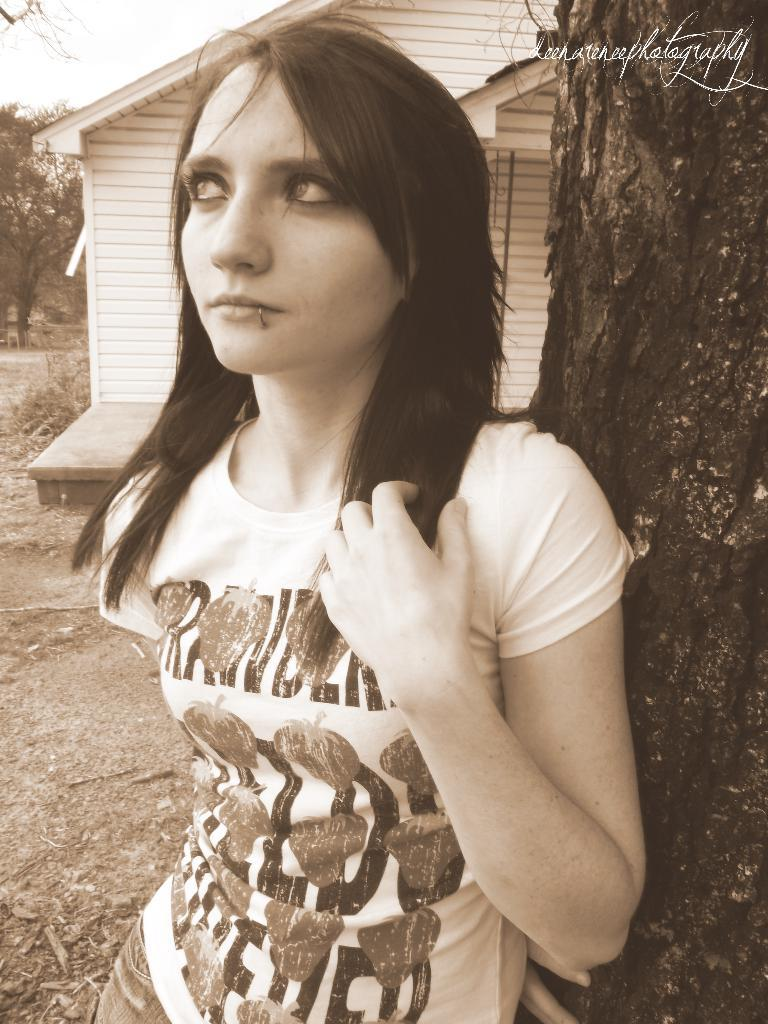What is the main subject in the image? There is a person standing in the image. What can be seen on the right side of the image? There is a tree trunk on the right side of the image. What type of structure is present in the image? There is a shack in the image. What is visible at the back of the image? Trees are present at the back of the image. What type of fan is visible in the image? There is no fan present in the image. What scene is depicted in the image? The image does not depict a specific scene; it shows a person, a tree trunk, a shack, and trees. 